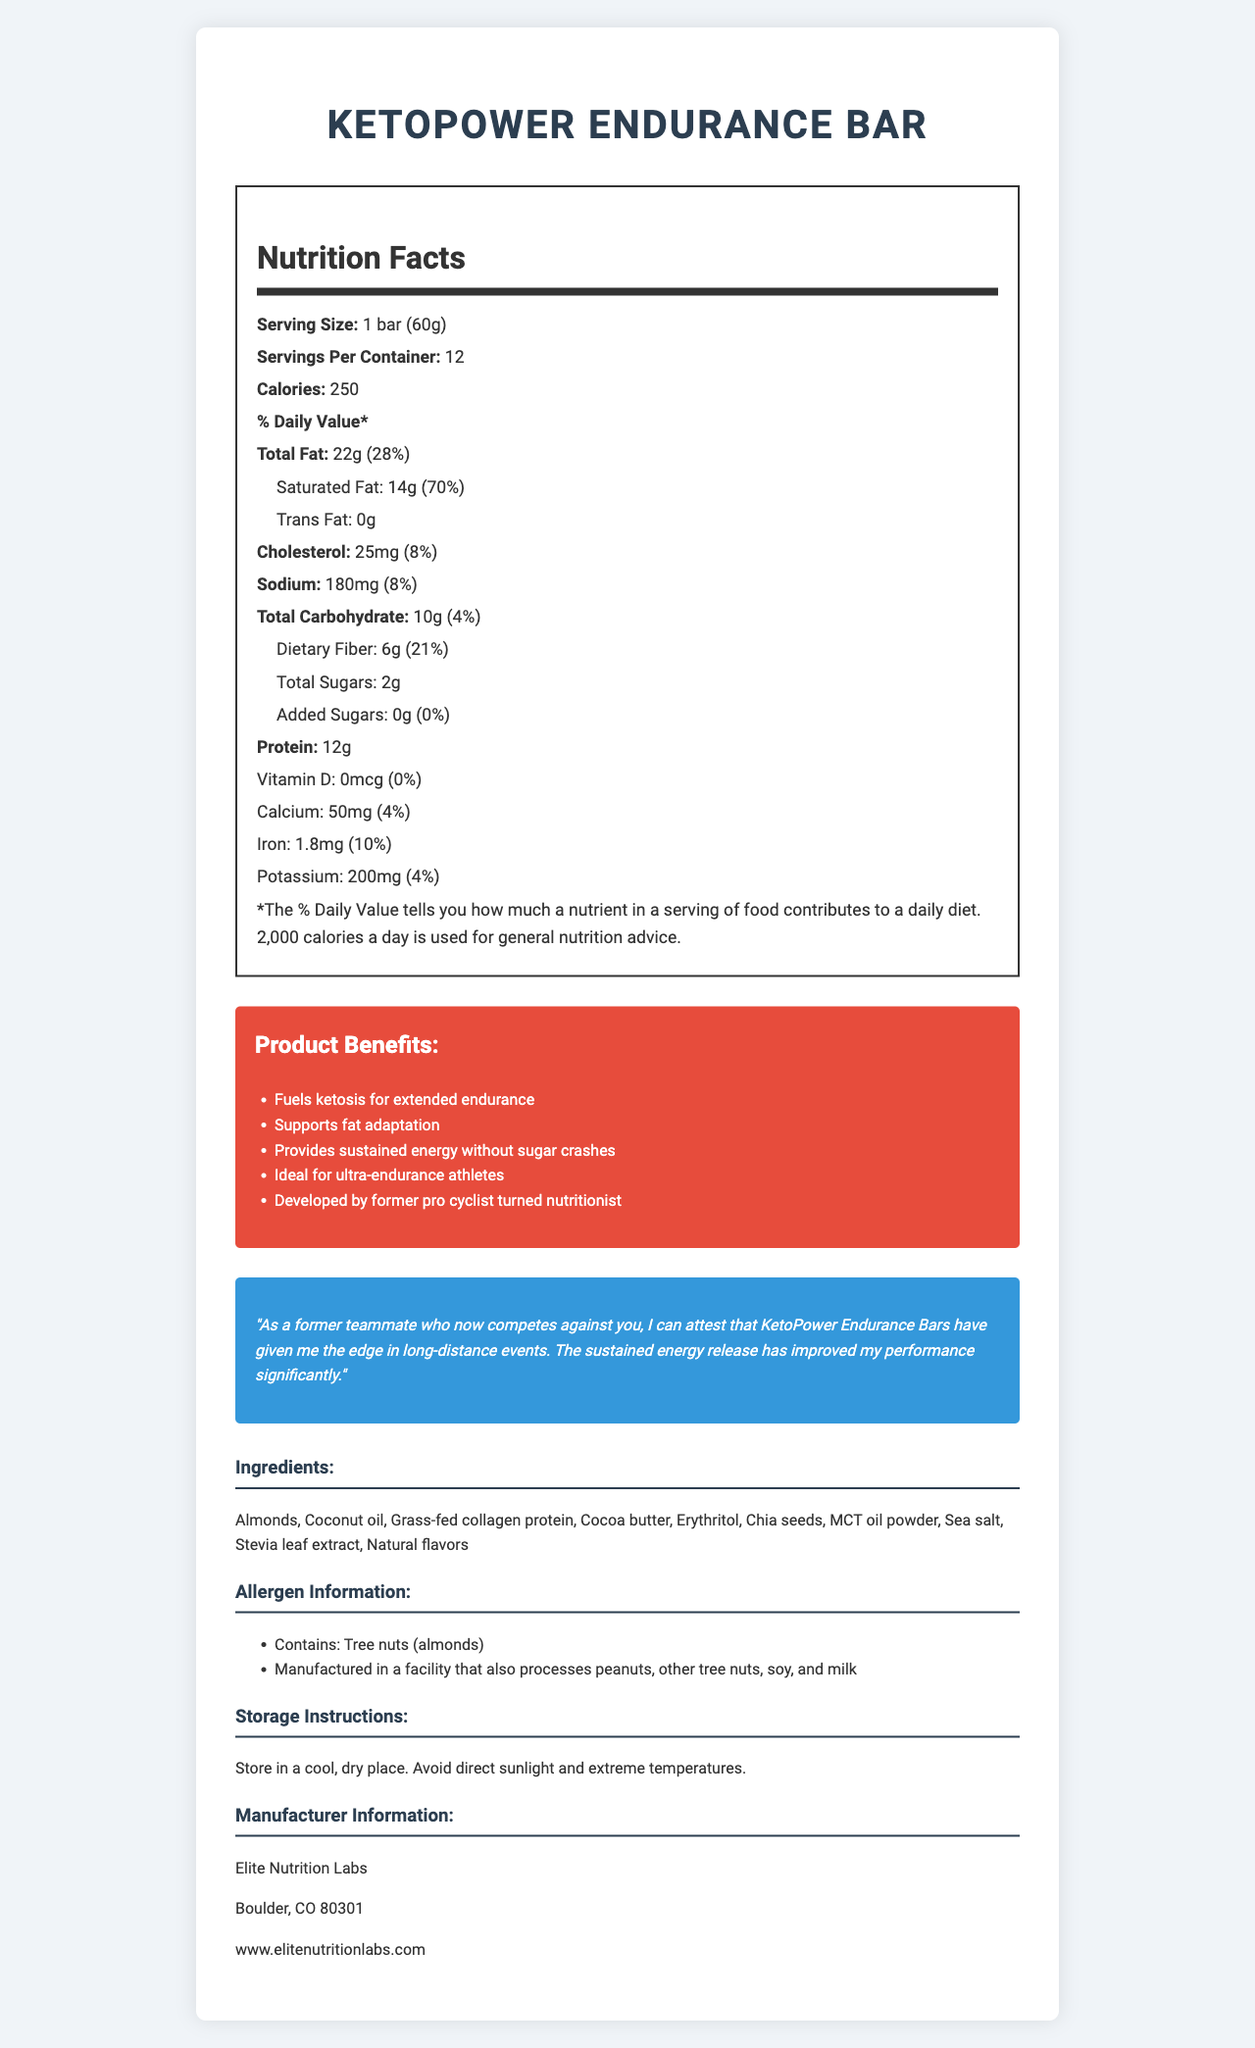what is the serving size of the KetoPower Endurance Bar? The serving size is stated under the 'Nutrition Facts' section as "Serving Size: 1 bar (60g)".
Answer: 1 bar (60g) how many calories are in one serving? The calories per serving are listed under the 'Nutrition Facts' section as "Calories: 250".
Answer: 250 how much total fat does the bar contain per serving? The total fat content per serving is listed under the 'Nutrition Facts' section as "Total Fat: 22g (28%)".
Answer: 22g how many grams of protein are in one bar? The protein content per bar is listed under the 'Nutrition Facts' section as "Protein: 12g".
Answer: 12g what are the allergens listed in the document? The allergen information is listed under the 'Allergen Information' section, which specifies "Contains: Tree nuts (almonds)" and "Manufactured in a facility that also processes peanuts, other tree nuts, soy, and milk".
Answer: Tree nuts (almonds) which ingredient is responsible for providing collagen protein? A. Almonds B. Coconut oil C. Grass-fed collagen protein The ingredients section lists "Grass-fed collagen protein," indicating it is responsible for providing collagen protein.
Answer: C what percentage of the daily value of saturated fat does one bar contain? A. 14% B. 70% C. 28% D. 8% Under the 'Nutrition Facts' section, saturated fat is listed as "Saturated Fat: 14g (70%)".
Answer: B does the bar contain any added sugars? The 'Nutrition Facts' section lists "Added Sugars: 0g (0%)", indicating there are no added sugars.
Answer: No is this bar suitable for ultra-endurance athletes? The marketing claims section includes the statement "Ideal for ultra-endurance athletes", suggesting it is suitable for them.
Answer: Yes summarize the main benefits of the KetoPower Endurance Bar. The marketing claims section highlights these main benefits, indicating the bar is designed to fuel ketosis, support fat adaptation, provide sustained energy, and is ideal for ultra-endurance athletes.
Answer: Fuels ketosis, supports fat adaptation, provides sustained energy without sugar crashes, ideal for ultra-endurance athletes. where is the manufacturer located? The manufacturer information section lists the location as "Boulder, CO 80301".
Answer: Boulder, CO 80301 can the exact nutritional breakdown of 'Coconut oil' be determined from this document? The document lists 'Coconut oil' as an ingredient but does not provide a detailed nutritional breakdown specific to this ingredient.
Answer: Not enough information 